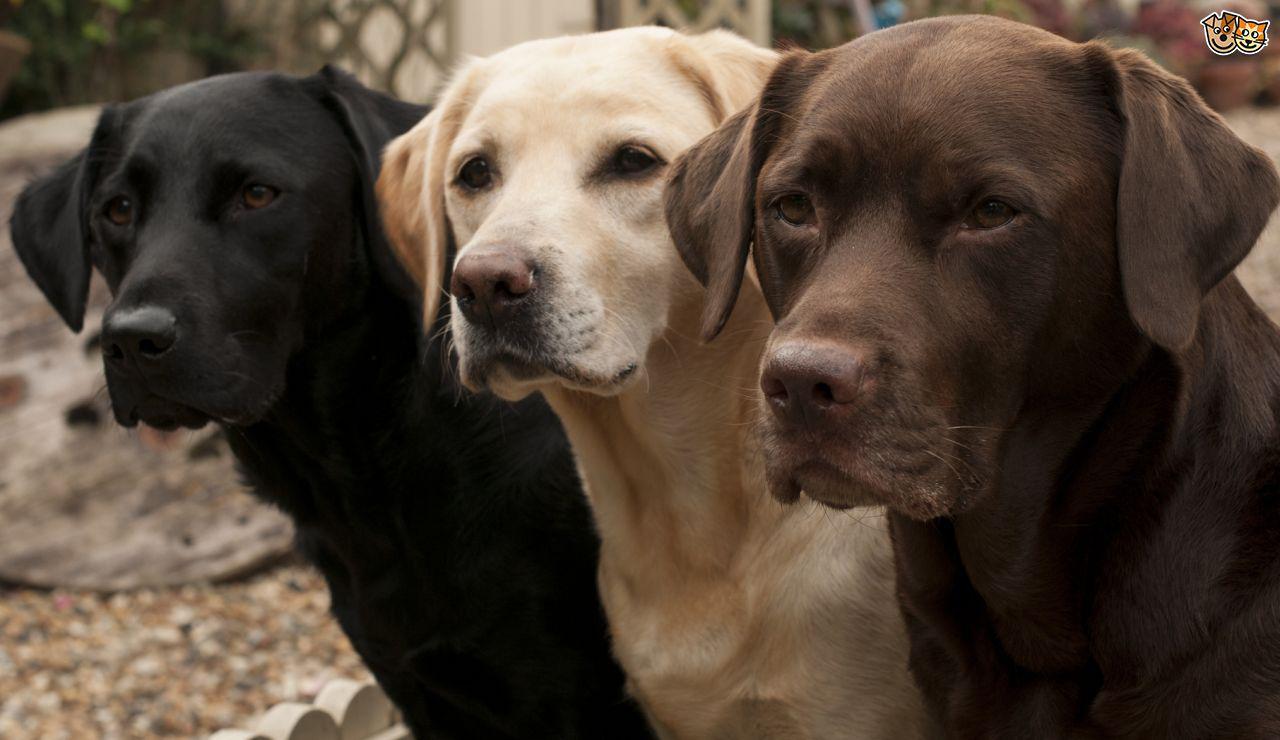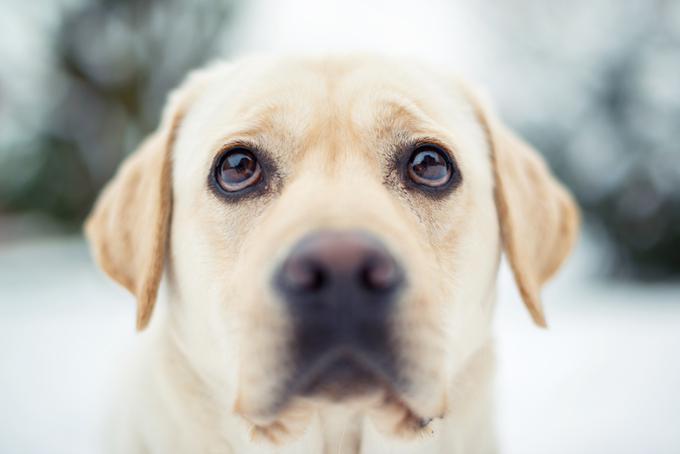The first image is the image on the left, the second image is the image on the right. Examine the images to the left and right. Is the description "There is one black dog" accurate? Answer yes or no. Yes. The first image is the image on the left, the second image is the image on the right. For the images shown, is this caption "The right image shows exactly two puppies side by side." true? Answer yes or no. No. 